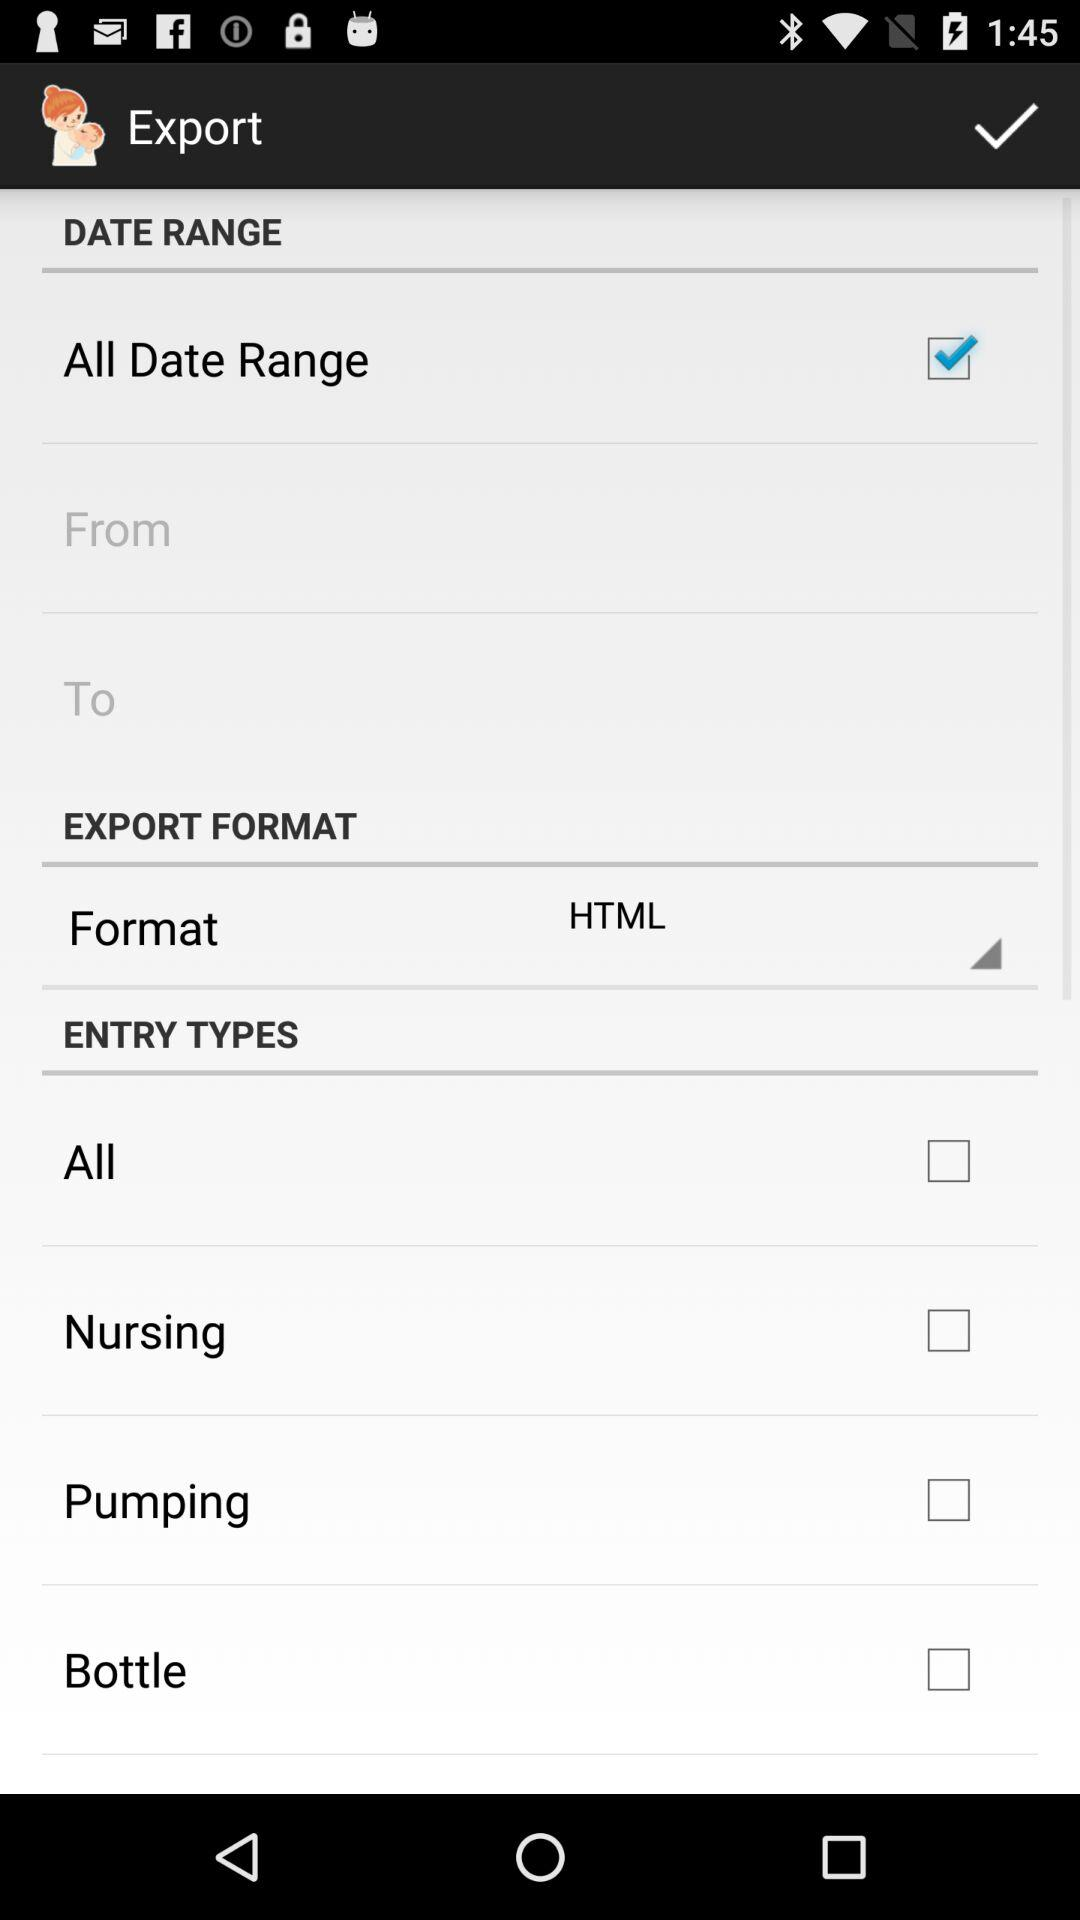What export format is used? The export format that is used is "HTML". 